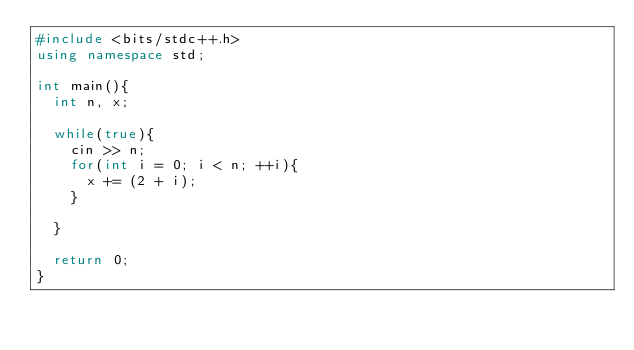<code> <loc_0><loc_0><loc_500><loc_500><_C++_>#include <bits/stdc++.h>
using namespace std;

int main(){
  int n, x;

  while(true){
    cin >> n;
    for(int i = 0; i < n; ++i){
      x += (2 + i);
    }
    
  }
    
  return 0;
}

</code> 